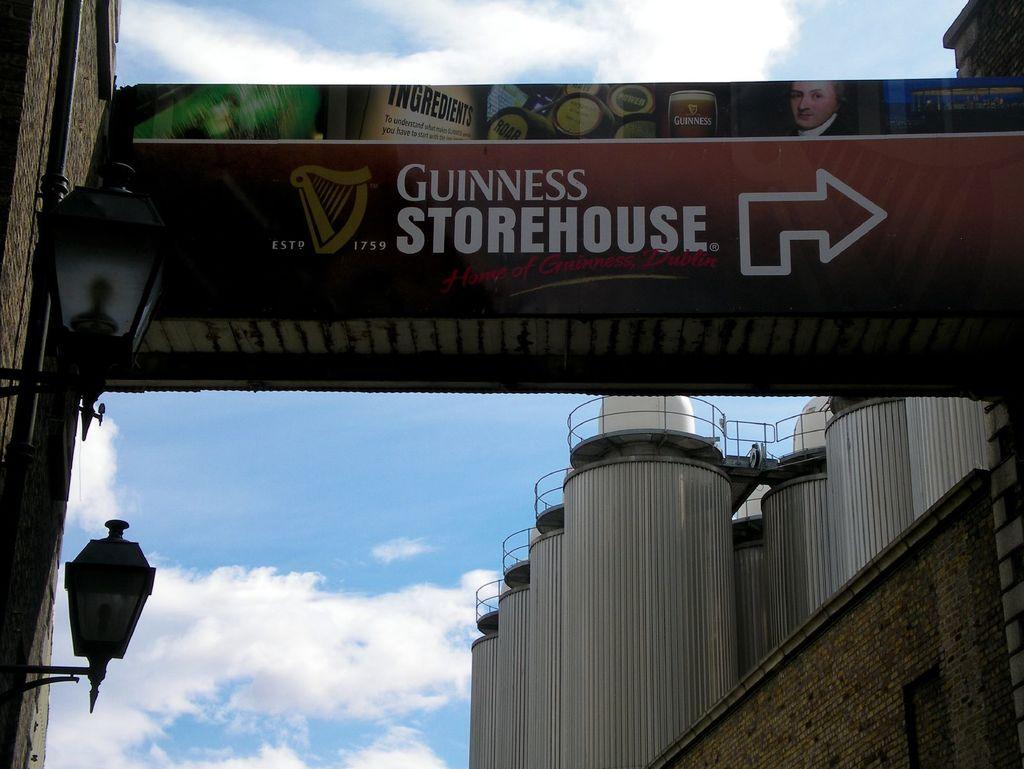<image>
Create a compact narrative representing the image presented. A sign's arrow points the way to the Guinness Storehouse. 